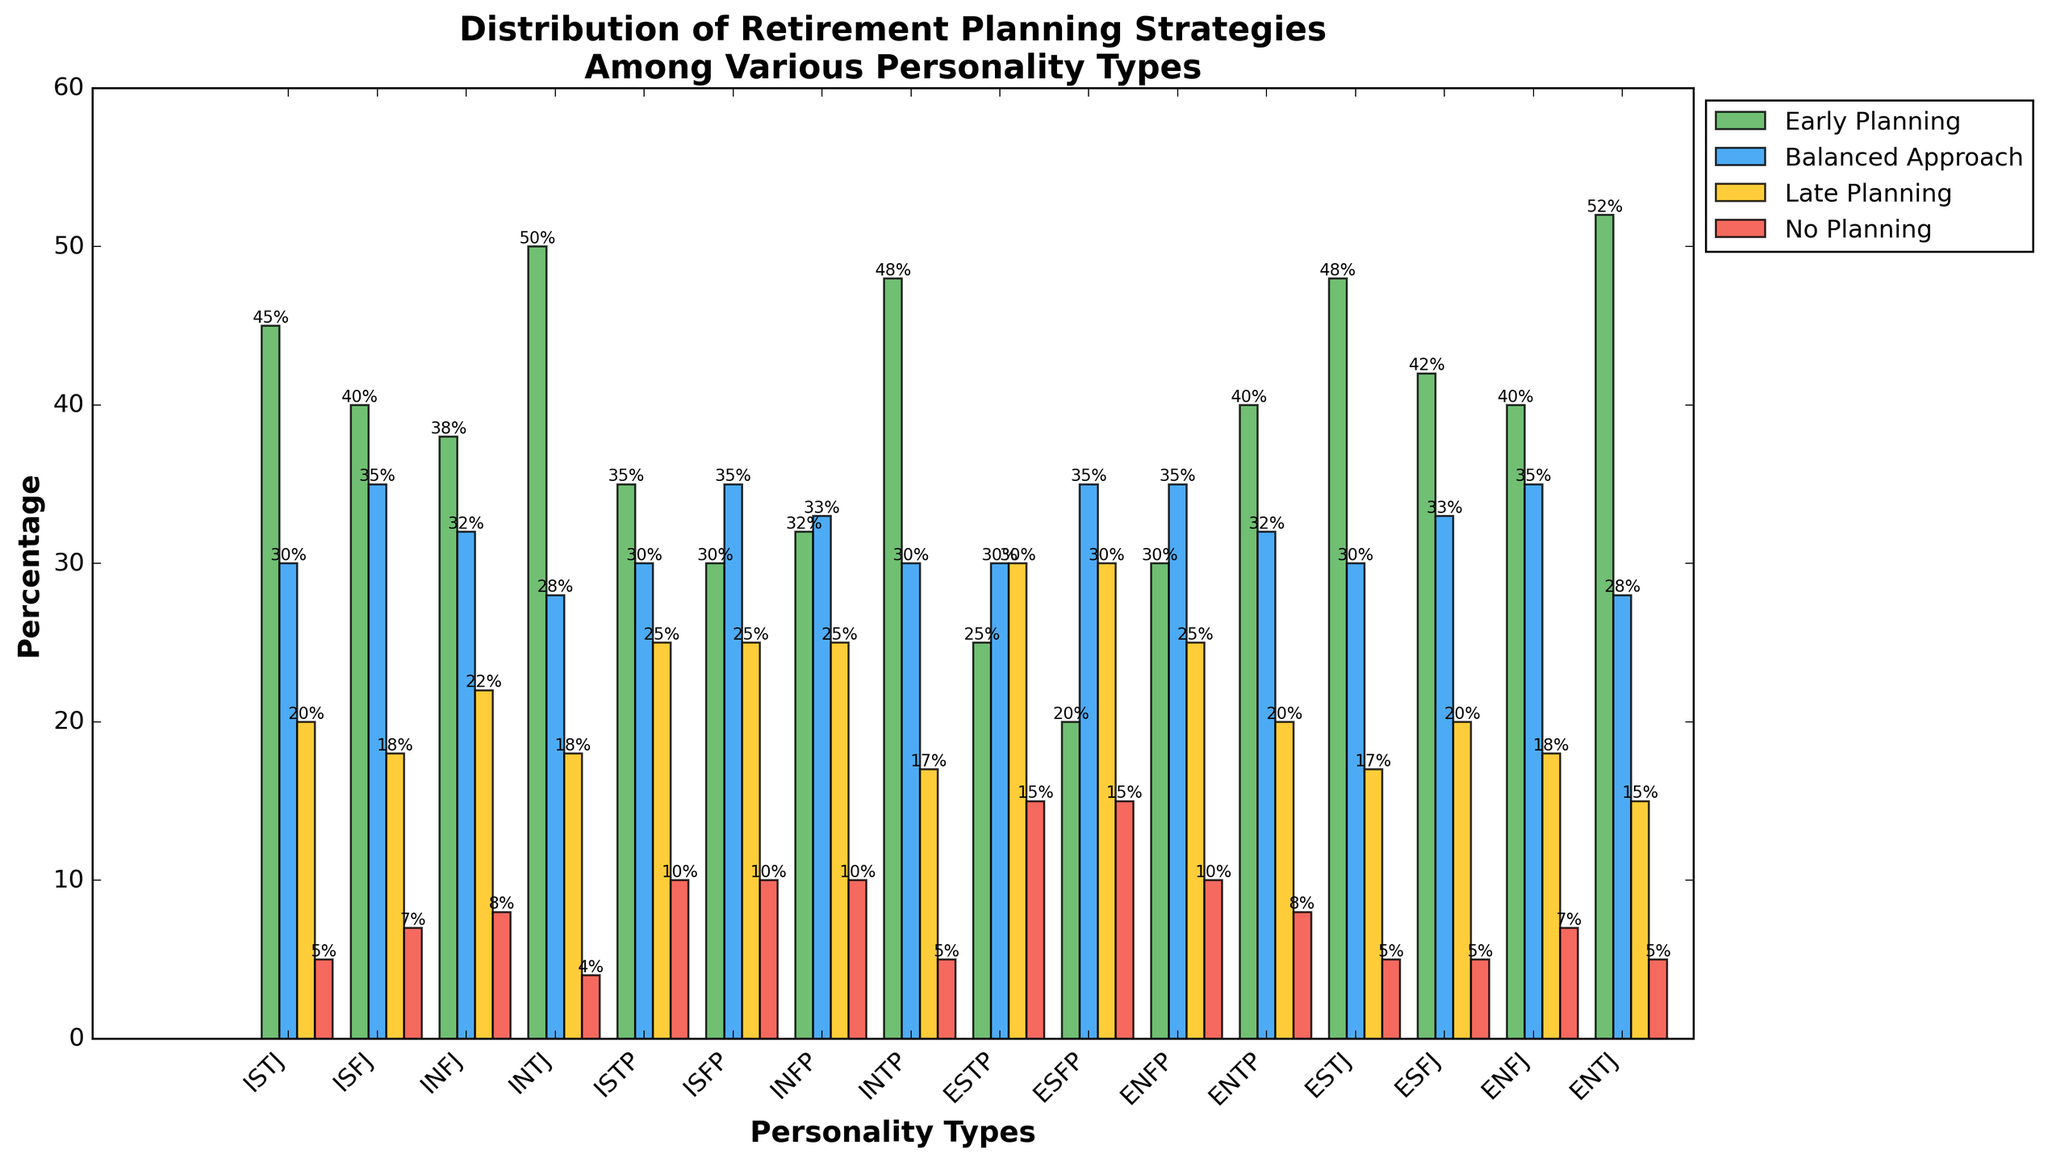what are the total percentages of people with INTJ personality type who plan late or don't plan at all? Summing up the 'Late Planning' and 'No Planning' percentages for INTJ, we have 18 (Late Planning) + 4 (No Planning). Therefore, the total is 22.
Answer: 22 Which personality type has the highest percentage of people following a balanced approach to retirement planning? By examining the heights of the blue bars (Balanced Approach), the ISFJ, ISFP, ENFP, and ENFJ all have the highest percentage at 35%.
Answer: ISFJ, ISFP, ENFP, ENFJ How does the percentage of ENTPs with an early planning strategy compare to INTPs with the same strategy? ENTP early planning is 40%, INTP early planning is 48%. Subtract the smaller value from the larger one: 48% - 40% = 8%.
Answer: INTPs have 8% more What is the total percentage of ISTPs who either plan early or use a balanced approach for retirement? Adding the 'Early Planning' and 'Balanced Approach' percentages for ISTP gives us 35 (Early Planning) + 30 (Balanced Approach) = 65.
Answer: 65 Which personality type has the smallest percentage of individuals who do not plan at all for their retirement? By looking at the heights of the red bars (No Planning), INTJ, INTP, ESTJ, ESFJ, and ENTJ all have the smallest percentage at 5%.
Answer: INTJ, INTP, ESTJ, ESFJ, ENTJ What is the average percentage of the 'Late Planning' strategy among all personality types? Summing up all 'Late Planning' percentages: 20 + 18 + 22 + 18 + 25 + 25 + 25 + 17 + 30 + 30 + 25 + 20 + 17 + 20 + 18 + 15 = 375. There are 16 personality types, so the average is 375 / 16 = 23.4375.
Answer: 23.4 Between INFP and ISTP, which one has a higher total percentage of people planning either early or not planning at all? Summing the 'Early Planning' and 'No Planning' for INFP: 32 (Early) + 10 (No) = 42. For ISTP: 35 (Early) + 10 (No) = 45. ISTP has the higher total.
Answer: ISTP Which two personality types have exactly equal percentages in all four planning strategies? By inspecting the graph, none of the personality types have exactly equal percentages in all four planning strategies.
Answer: None 